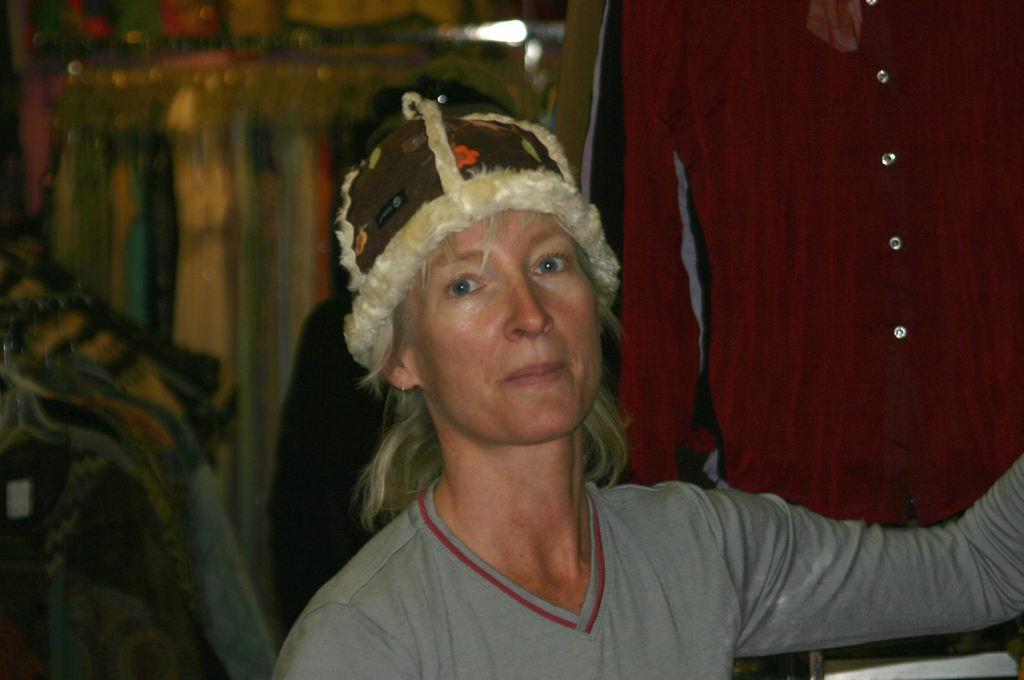Please provide a concise description of this image. In this image I can see a person wearing grey colored dress and hat. I can see few clothes are hanged behind her and the blurry background. 